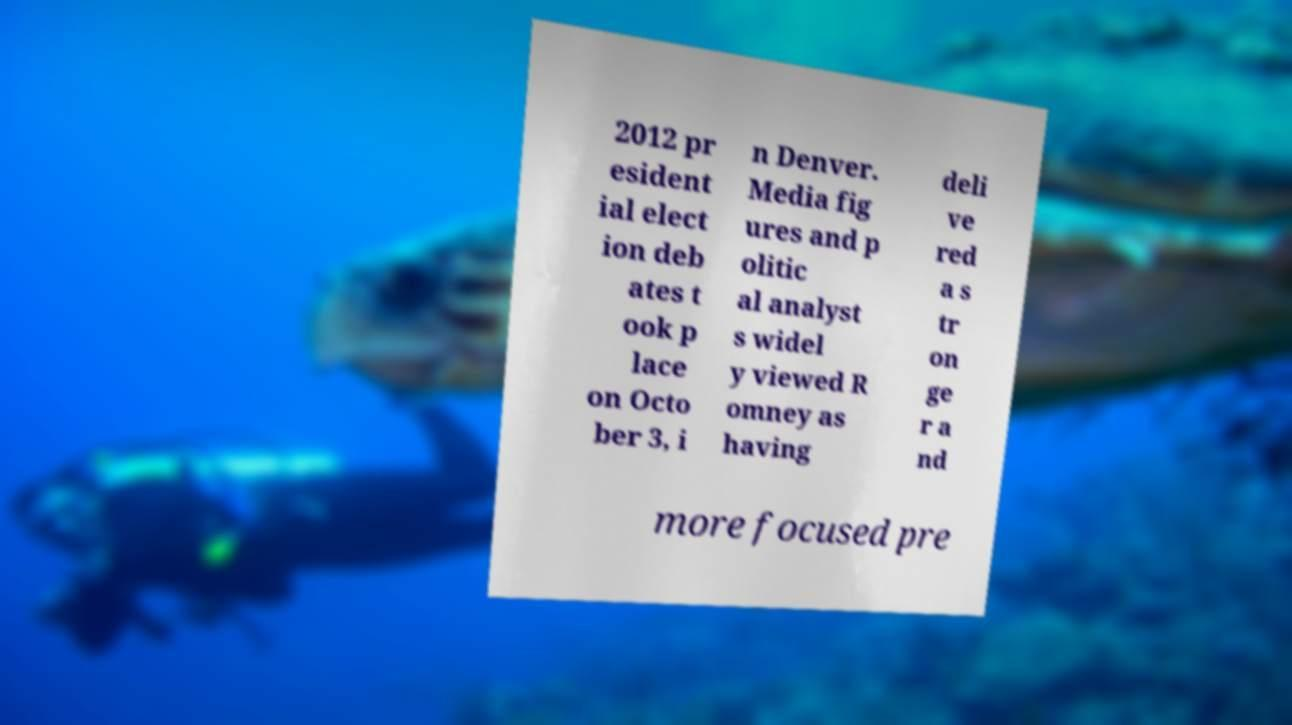I need the written content from this picture converted into text. Can you do that? 2012 pr esident ial elect ion deb ates t ook p lace on Octo ber 3, i n Denver. Media fig ures and p olitic al analyst s widel y viewed R omney as having deli ve red a s tr on ge r a nd more focused pre 